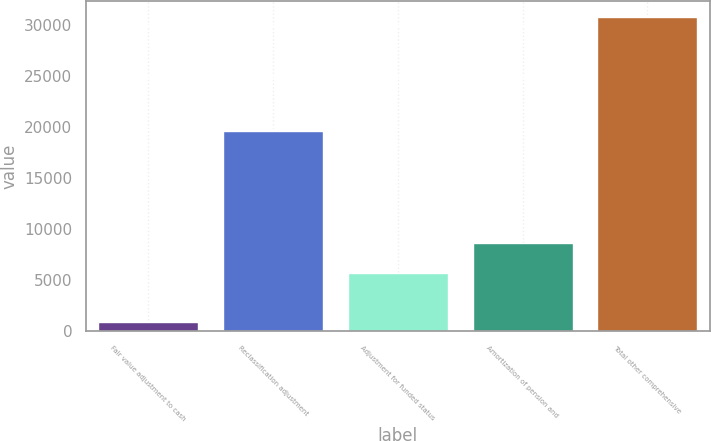Convert chart. <chart><loc_0><loc_0><loc_500><loc_500><bar_chart><fcel>Fair value adjustment to cash<fcel>Reclassification adjustment<fcel>Adjustment for funded status<fcel>Amortization of pension and<fcel>Total other comprehensive<nl><fcel>882<fcel>19619<fcel>5683<fcel>8673.9<fcel>30791<nl></chart> 